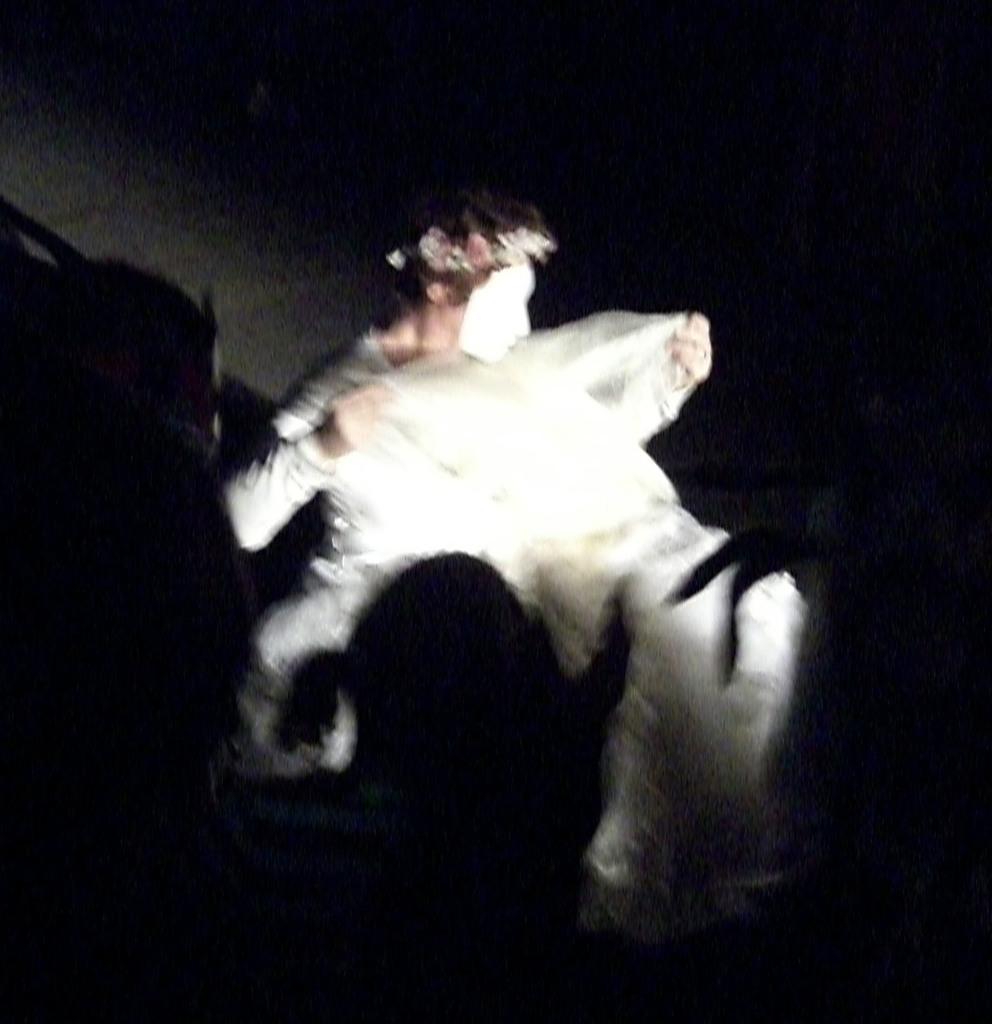Please provide a concise description of this image. In the picture I can see a person with a mask on the face and looks like the person is holding a white cloth. I can see the shadows of persons at the bottom of the picture. 